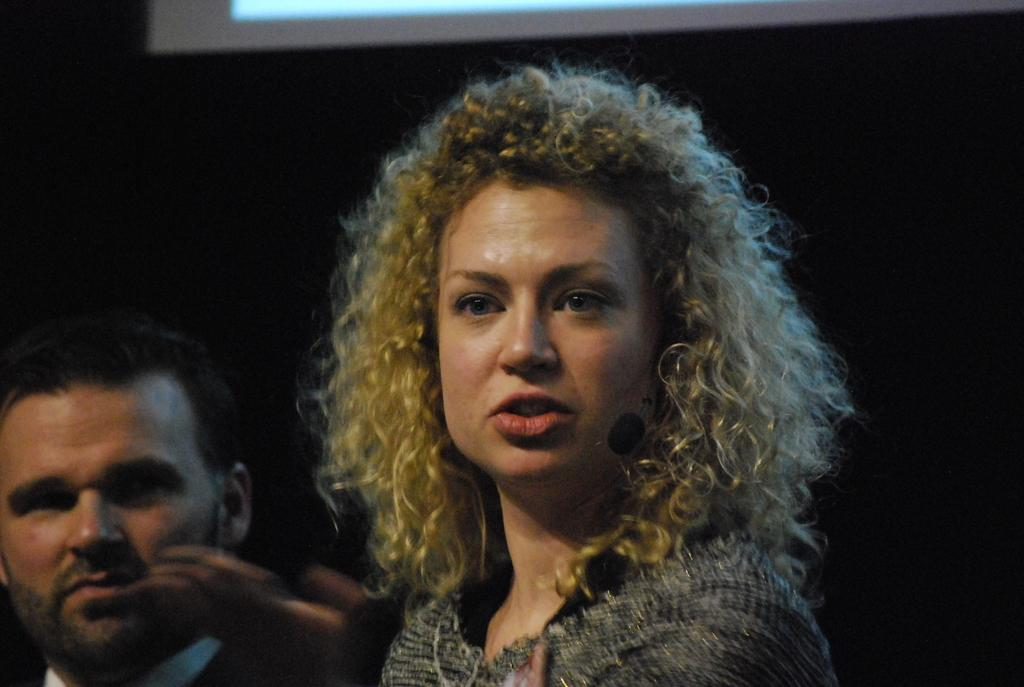Who are the people in the image? There is a woman and a man in the image. What can be observed about the background of the image? The background of the image is black in color. What type of pie is the woman holding in the image? There is no pie present in the image; the woman is not holding anything. 